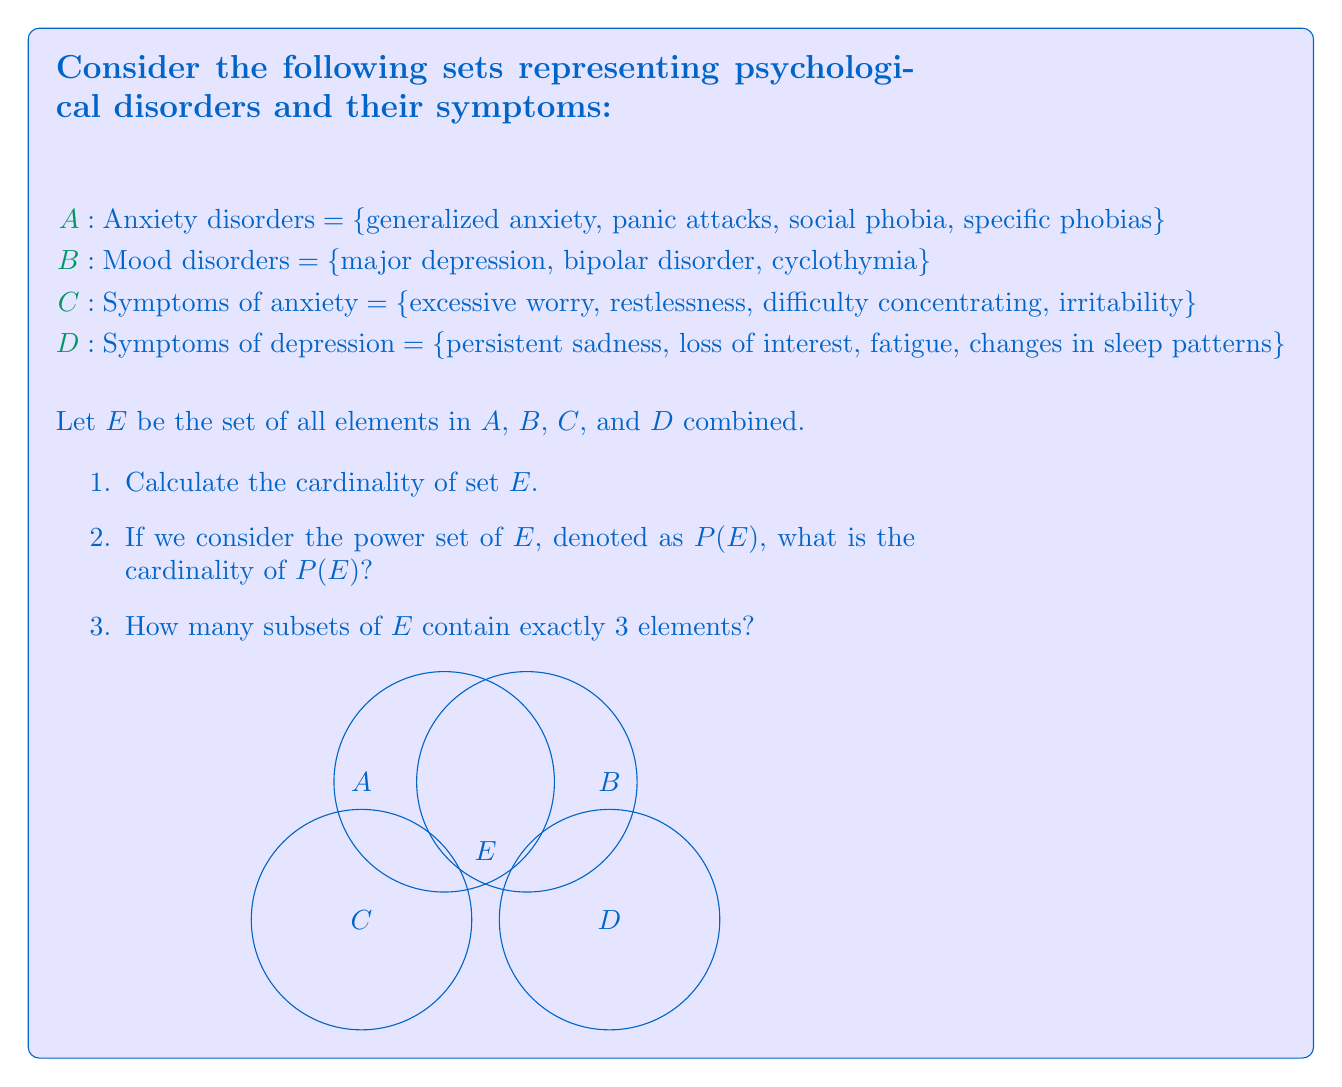Solve this math problem. Let's approach this step-by-step:

1. To find the cardinality of set E:
   - Count the unique elements in all sets
   - A has 4 elements
   - B has 3 elements
   - C has 4 elements
   - D has 4 elements
   - Total: 4 + 3 + 4 + 4 = 15
   - Therefore, |E| = 15

2. For the power set P(E):
   - The cardinality of a power set is given by the formula: |P(E)| = 2^|E|
   - We know |E| = 15
   - Therefore, |P(E)| = 2^15 = 32,768

3. For subsets with exactly 3 elements:
   - This is a combination problem
   - We're choosing 3 elements from a set of 15
   - The formula for this is $\binom{15}{3}$
   - $\binom{15}{3} = \frac{15!}{3!(15-3)!} = \frac{15!}{3!12!}$
   - $\binom{15}{3} = \frac{15 \cdot 14 \cdot 13}{3 \cdot 2 \cdot 1} = 455$

From a psychoanalytic perspective, this analysis allows us to quantify the complexity of psychological disorders and their symptoms. The large number of possible subsets (32,768) reflects the intricate combinations of disorders and symptoms that clinicians must consider in diagnosis and treatment.
Answer: 1. |E| = 15
2. |P(E)| = 32,768
3. 455 subsets 